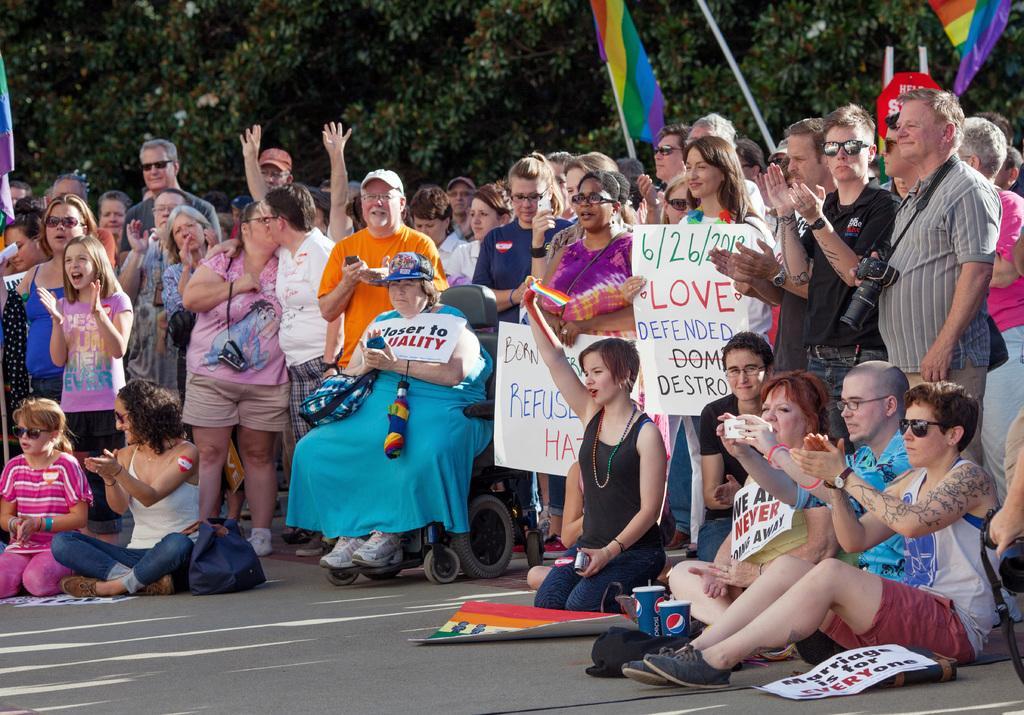Please provide a concise description of this image. This image is taken outdoors. At the bottom of the image there is a road. In the background there are many tree and there are a few flags. In the middle of the image many people are standing on the road and a few are holding posters with text on them and a woman is sitting on the wheel chair. A few people are sitting on the road and there are a few tumblers and a board with text on it. 